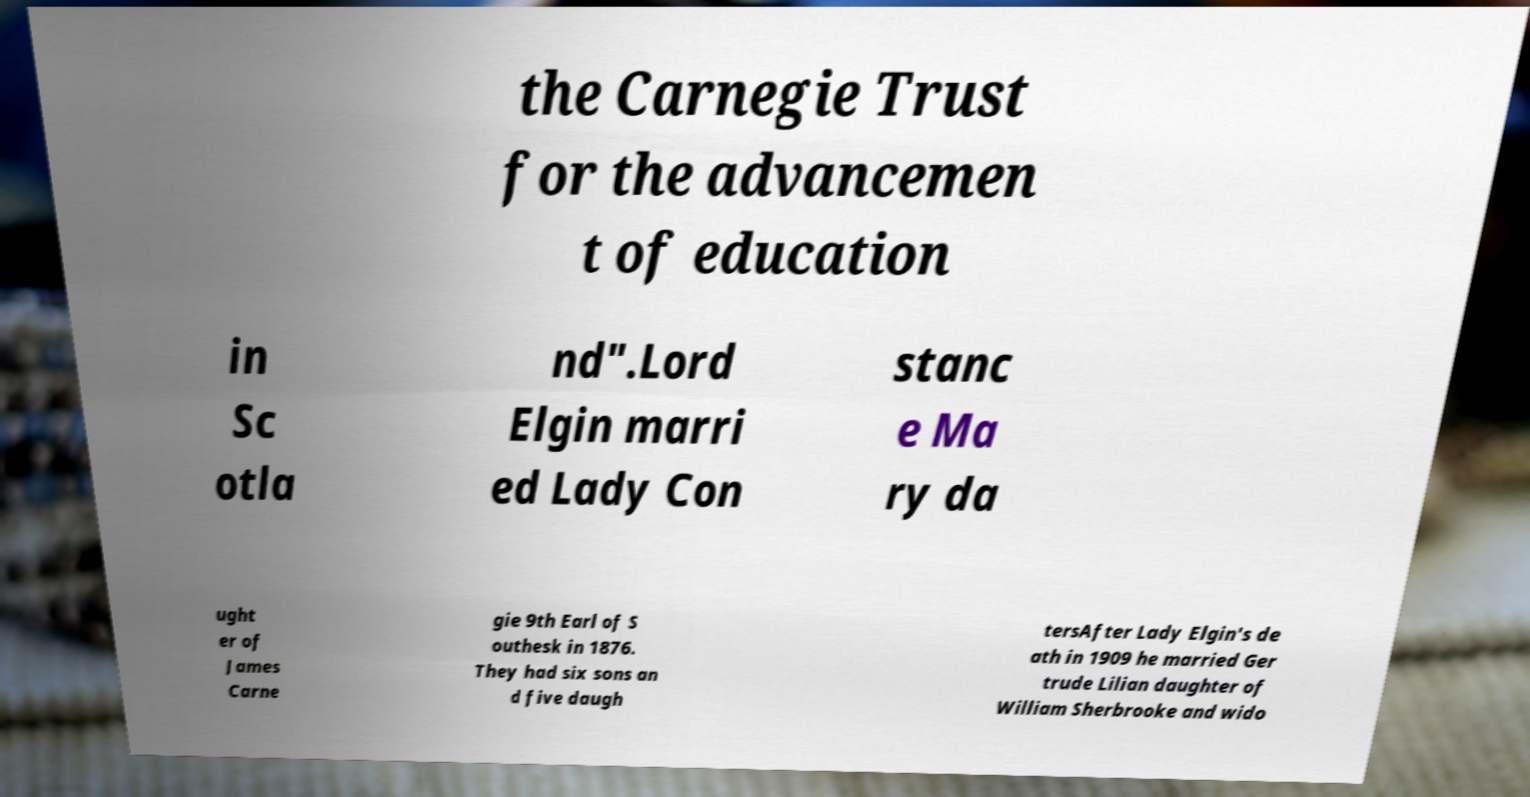Please identify and transcribe the text found in this image. the Carnegie Trust for the advancemen t of education in Sc otla nd".Lord Elgin marri ed Lady Con stanc e Ma ry da ught er of James Carne gie 9th Earl of S outhesk in 1876. They had six sons an d five daugh tersAfter Lady Elgin's de ath in 1909 he married Ger trude Lilian daughter of William Sherbrooke and wido 